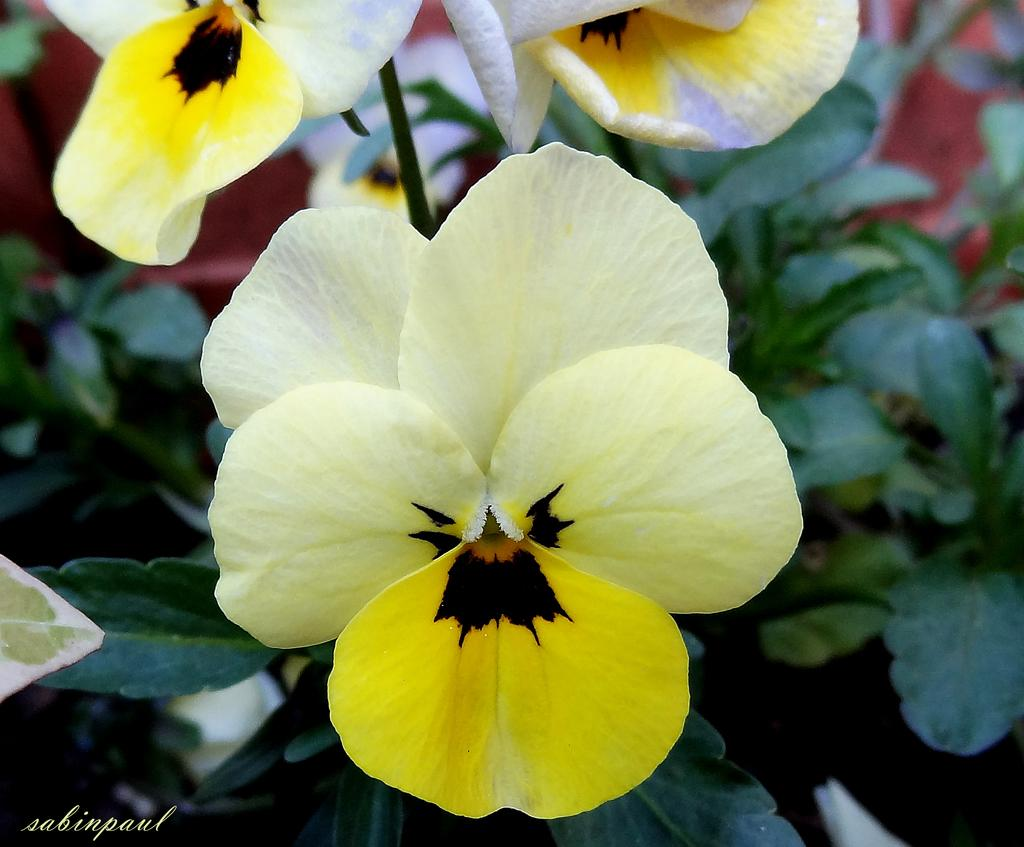What type of living organisms can be seen in the image? Plants and flowers are visible in the image. What color are the flowers in the image? The flowers in the image are yellow in color. Is there a stream of water flowing through the flowers in the image? No, there is no stream of water visible in the image. 